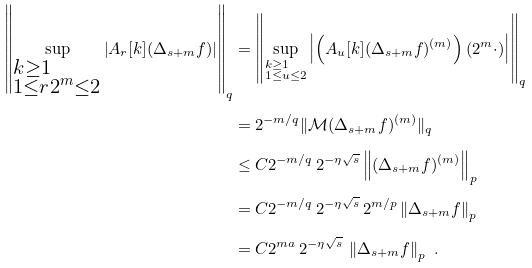Convert formula to latex. <formula><loc_0><loc_0><loc_500><loc_500>\left \| \sup _ { \begin{subarray} { c } k \geq 1 \\ 1 \leq r 2 ^ { m } \leq 2 \end{subarray} } \left | A _ { r } [ k ] ( \Delta _ { s + m } f ) \right | \right \| _ { q } & = \left \| \sup _ { \begin{subarray} { c } k \geq 1 \\ 1 \leq u \leq 2 \end{subarray} } \left | \left ( A _ { u } [ k ] ( \Delta _ { s + m } f ) ^ { ( m ) } \right ) ( 2 ^ { m } \cdot ) \right | \right \| _ { q } \\ & = 2 ^ { - m / q } \| \mathcal { M } ( \Delta _ { s + m } f ) ^ { ( m ) } \| _ { q } \\ & \leq C 2 ^ { - m / q } \, 2 ^ { - \eta \sqrt { s } } \left \| ( \Delta _ { s + m } f ) ^ { ( m ) } \right \| _ { p } \\ & = C 2 ^ { - m / q } \, 2 ^ { - \eta \sqrt { s } } \, 2 ^ { m / p } \left \| \Delta _ { s + m } f \right \| _ { p } \\ & = C 2 ^ { m a } \, 2 ^ { - \eta \sqrt { s } } \, \left \| \Delta _ { s + m } f \right \| _ { p } \ . \\</formula> 